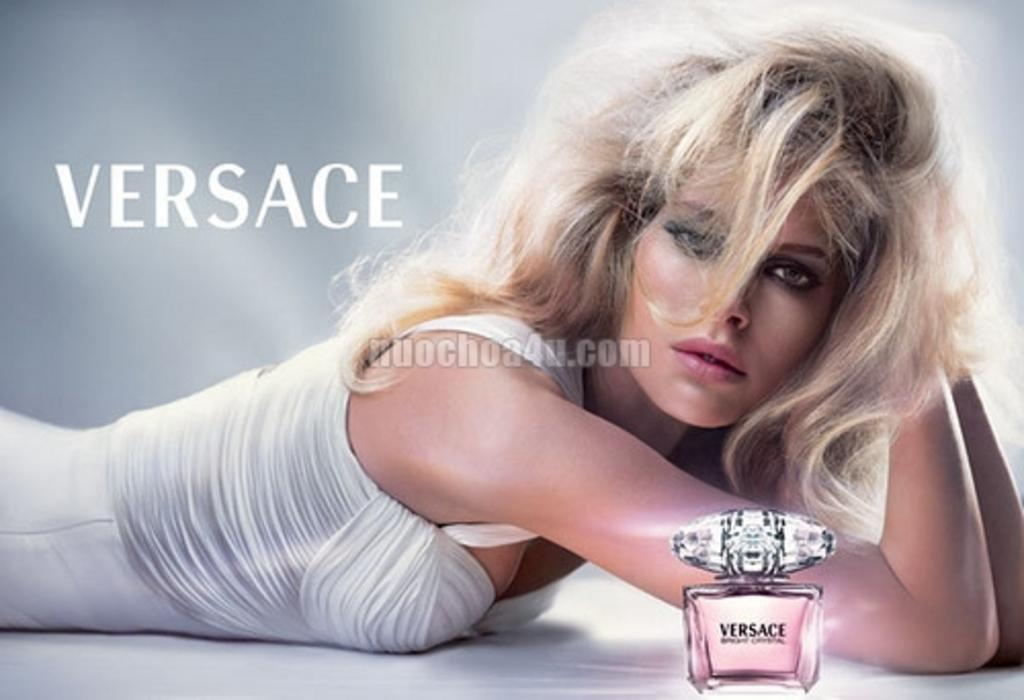<image>
Offer a succinct explanation of the picture presented. A woman sits behind a bottle of Versace perfume. 